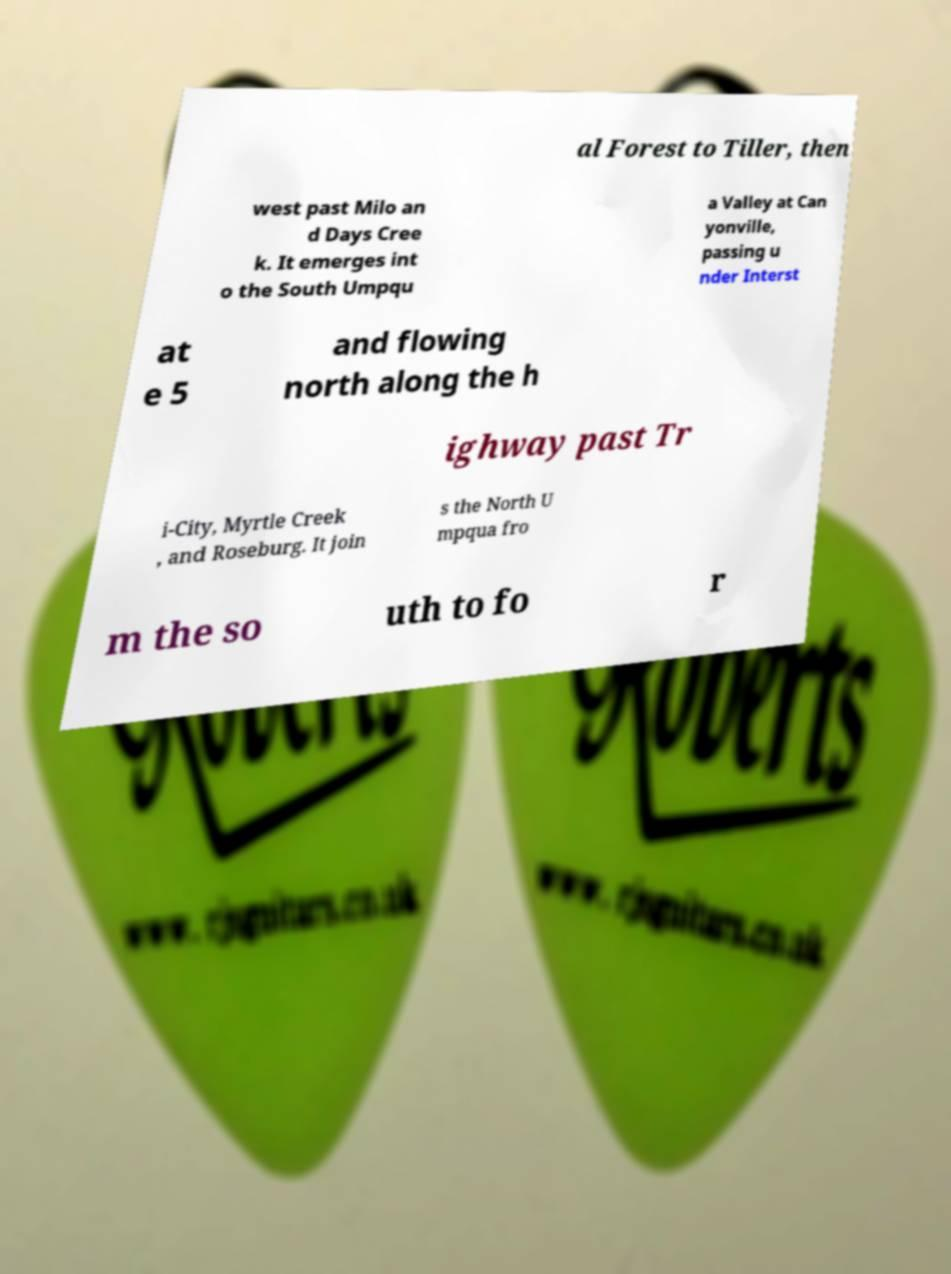Could you assist in decoding the text presented in this image and type it out clearly? al Forest to Tiller, then west past Milo an d Days Cree k. It emerges int o the South Umpqu a Valley at Can yonville, passing u nder Interst at e 5 and flowing north along the h ighway past Tr i-City, Myrtle Creek , and Roseburg. It join s the North U mpqua fro m the so uth to fo r 